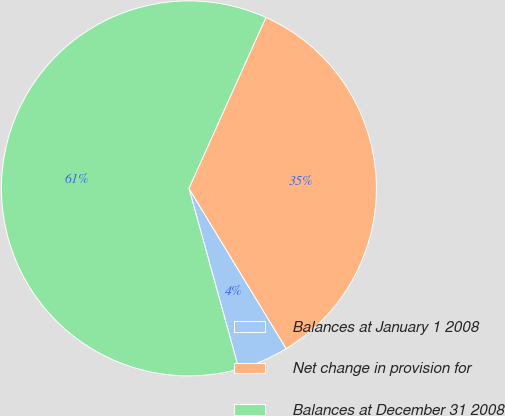Convert chart. <chart><loc_0><loc_0><loc_500><loc_500><pie_chart><fcel>Balances at January 1 2008<fcel>Net change in provision for<fcel>Balances at December 31 2008<nl><fcel>4.39%<fcel>34.58%<fcel>61.02%<nl></chart> 